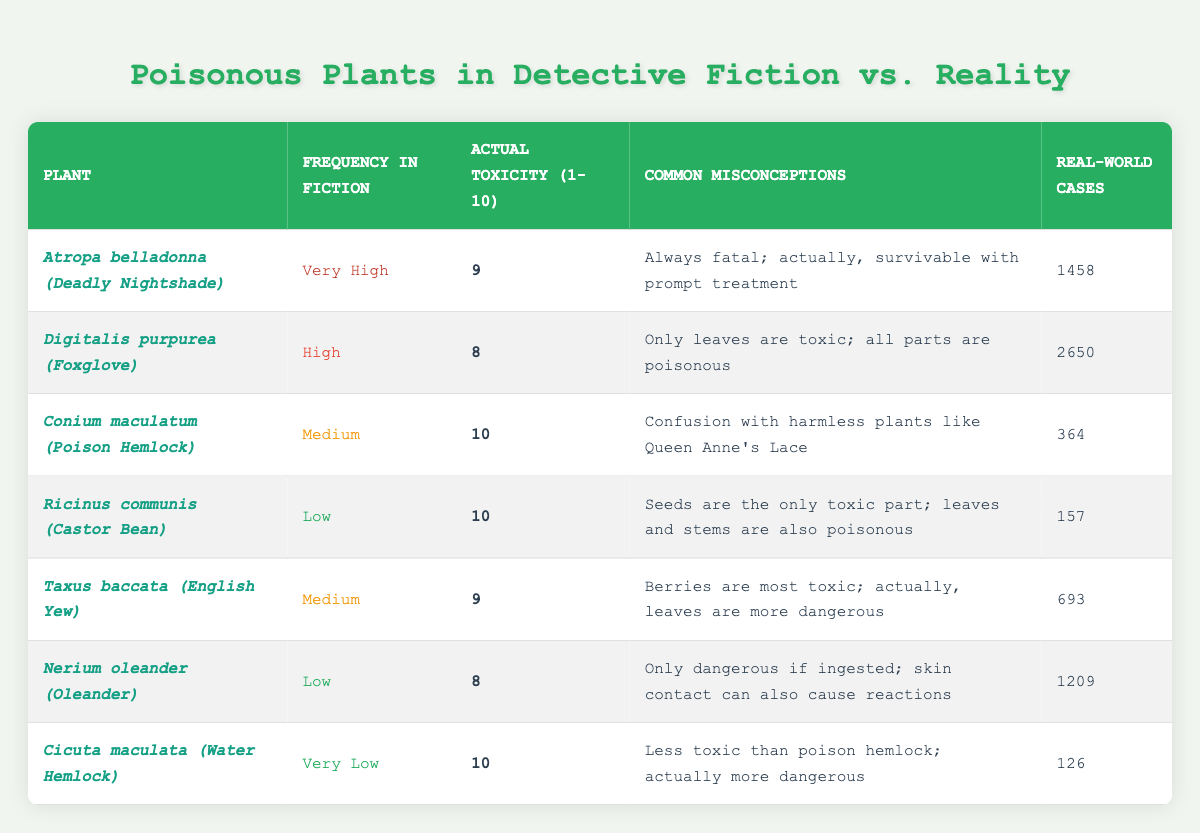What is the actual toxicity level of Atropa belladonna? The table states the actual toxicity level of Atropa belladonna (Deadly Nightshade) is listed as 9.
Answer: 9 Which plant has the highest frequency in classic detective fiction? By scanning the 'Frequency in Classic Detective Fiction' column, Atropa belladonna has the highest frequency marked as 'Very High'.
Answer: Atropa belladonna What is the total number of real-world poisoning cases for all the plants listed? To find the total, sum the real-world poisoning cases: 1458 + 2650 + 364 + 157 + 693 + 1209 + 126 = 5657.
Answer: 5657 Is it true that Digitalis purpurea's only toxic part is its leaves? According to the Common Misconceptions column in the table, Digitalis purpurea is commonly misunderstood as only the leaves being toxic, but it's stated that all parts are poisonous, confirming this is false.
Answer: No What is the average actual toxicity level of the plants listed in the table? The actual toxicity levels are 9, 8, 10, 10, 9, 8, and 10. Summing these gives 74, and dividing by the 7 plants results in an average of 10.57, rounded down, makes it 10.
Answer: 10 Which plant has the most real-world poisoning cases, and how many are there? By examining the Real-world Poisoning Cases column, Digitalis purpurea has the highest at 2650 cases.
Answer: Digitalis purpurea, 2650 What common misconception is associated with Ricinus communis? The table lists that the common misconception about Ricinus communis (Castor Bean) is that only the seeds are toxic, while the truth is that leaves and stems are also poisonous.
Answer: Seeds are the only toxic part How many plants in the table have a medium frequency of representation in detective fiction? Upon reviewing the Frequency in Classic Detective Fiction column, there are two plants with a medium representation: Conium maculatum and Taxus baccata.
Answer: 2 